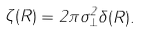Convert formula to latex. <formula><loc_0><loc_0><loc_500><loc_500>\zeta ( { R } ) = 2 \pi \sigma _ { \perp } ^ { 2 } \delta ( { R } ) .</formula> 